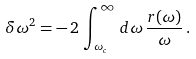Convert formula to latex. <formula><loc_0><loc_0><loc_500><loc_500>\delta \omega ^ { 2 } = - \, 2 \, \int _ { \omega _ { c } } ^ { \infty } \, d \omega \, \frac { r ( \omega ) } { \omega } \, .</formula> 